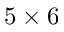<formula> <loc_0><loc_0><loc_500><loc_500>5 \times 6</formula> 